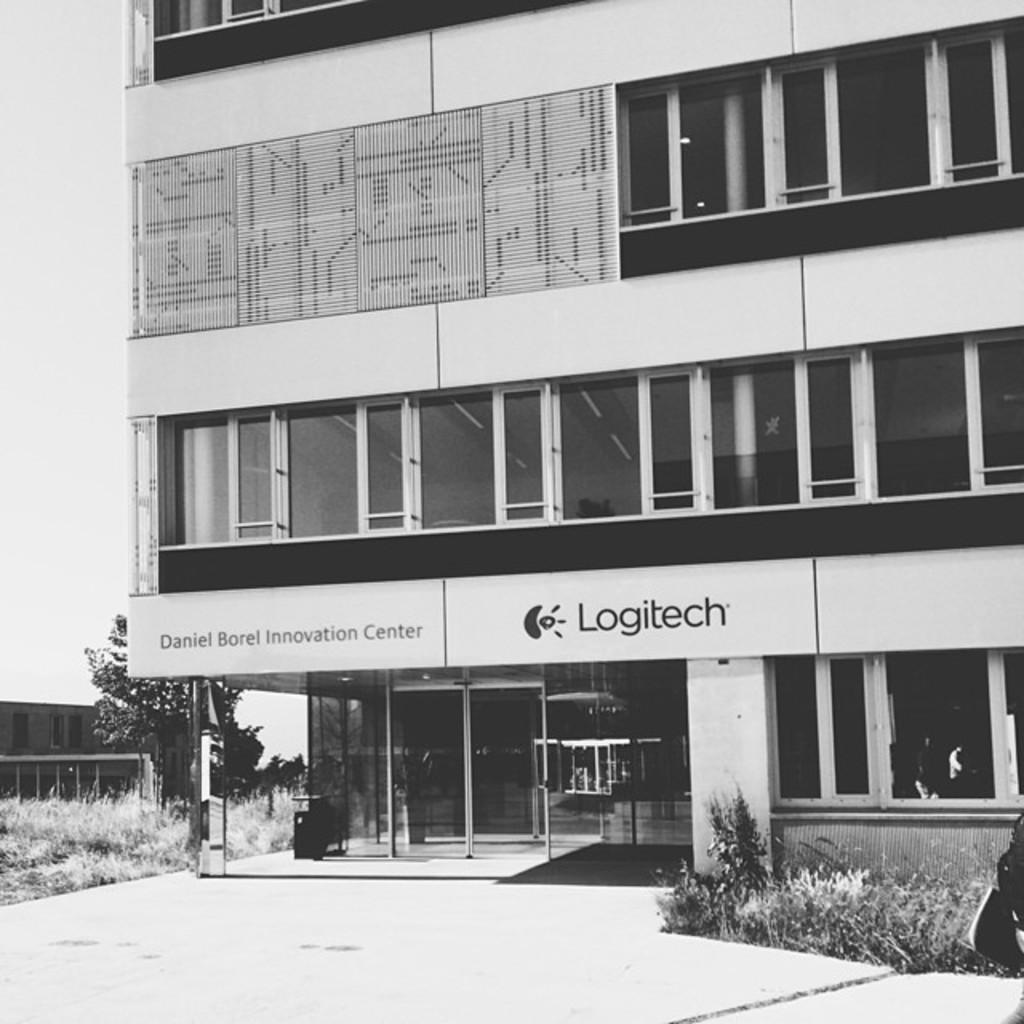What type of structures are visible in the image? There are buildings in the image. What natural elements can be seen in the image? There are trees and grass in the image. What architectural features are present in the buildings? There are glass windows and doors in the image. What is the color scheme of the image? The image is in black and white. How many planes are flying in the image? There are no planes visible in the image; it features include buildings, trees, grass, glass windows, doors, and a black and white color scheme. 